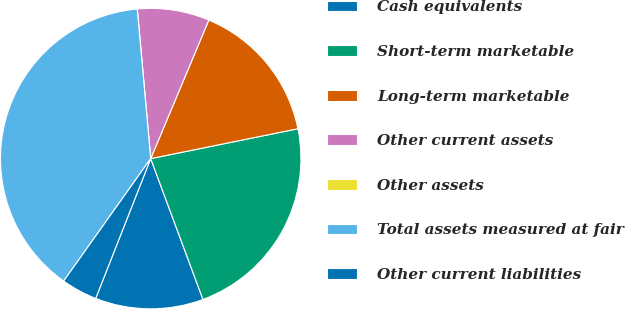Convert chart. <chart><loc_0><loc_0><loc_500><loc_500><pie_chart><fcel>Cash equivalents<fcel>Short-term marketable<fcel>Long-term marketable<fcel>Other current assets<fcel>Other assets<fcel>Total assets measured at fair<fcel>Other current liabilities<nl><fcel>11.62%<fcel>22.53%<fcel>15.49%<fcel>7.75%<fcel>0.0%<fcel>38.73%<fcel>3.87%<nl></chart> 